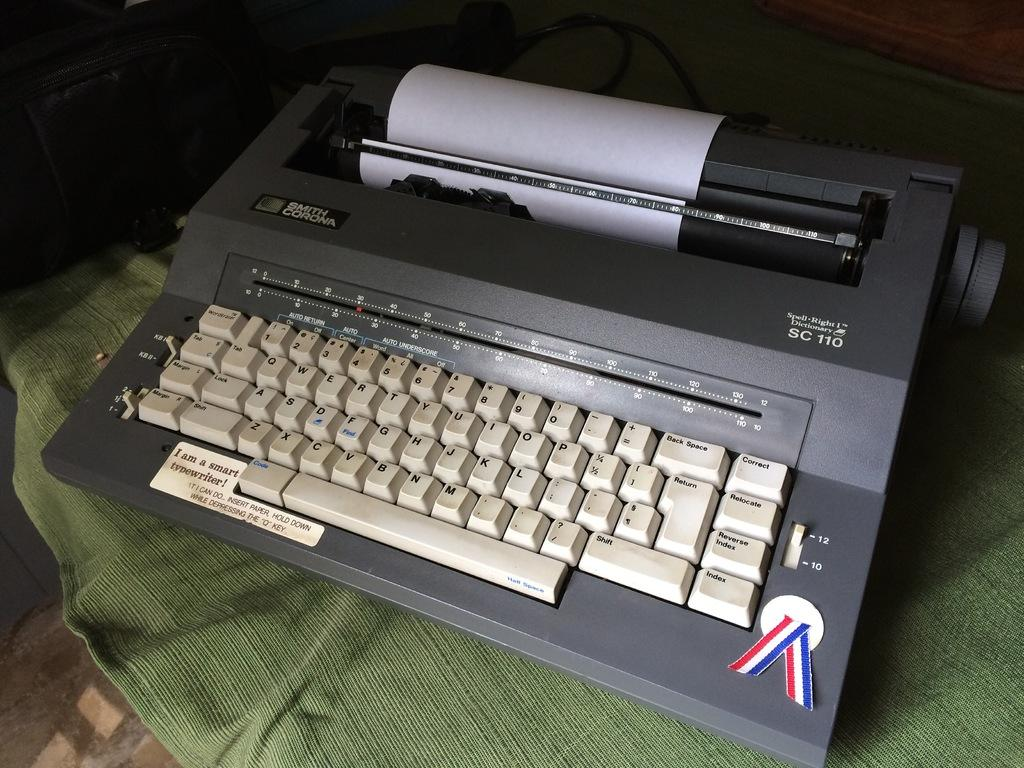<image>
Create a compact narrative representing the image presented. A Smith Corona typewriter with a small red, white, and blue ribbon on the bottom corner. 